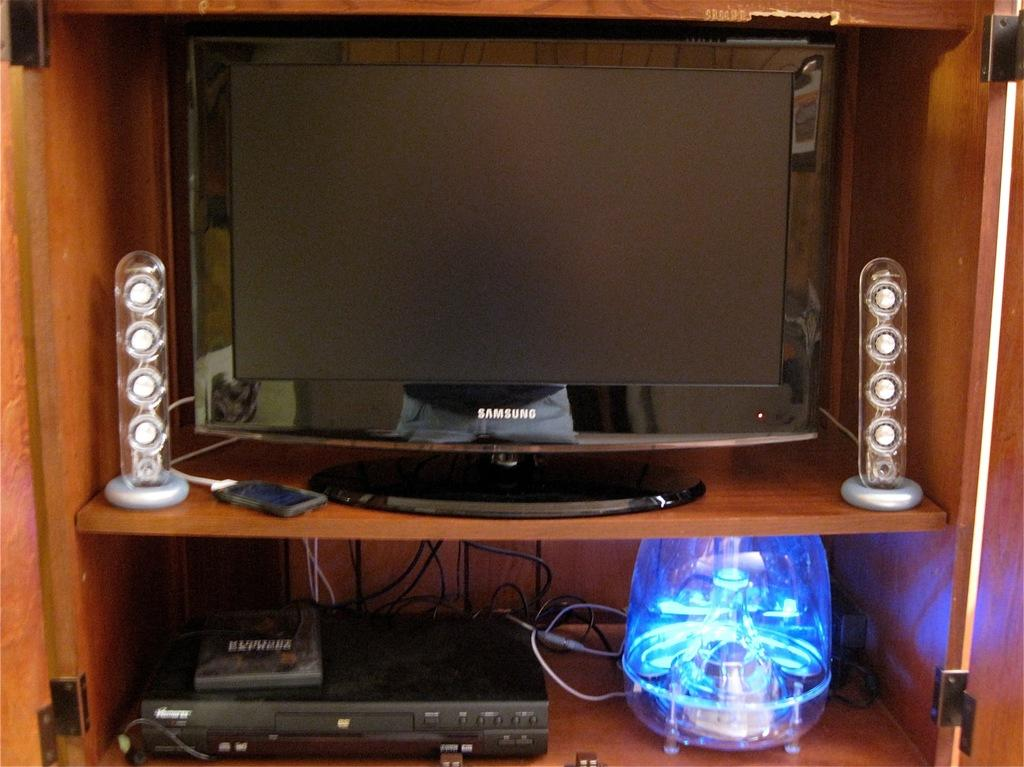<image>
Give a short and clear explanation of the subsequent image. A Samsung monitor is set up in a wood cabinet above a DVD player. 